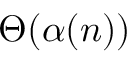Convert formula to latex. <formula><loc_0><loc_0><loc_500><loc_500>\Theta ( \alpha ( n ) )</formula> 